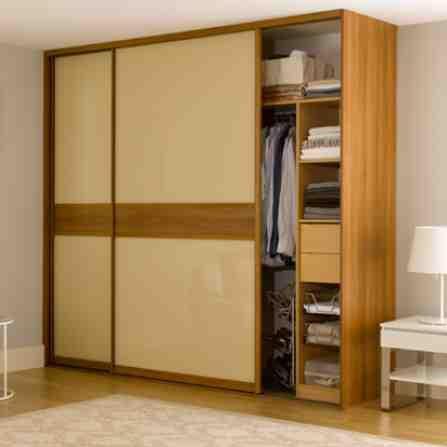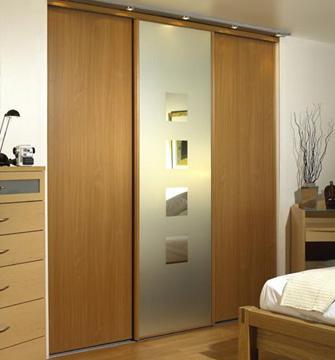The first image is the image on the left, the second image is the image on the right. Assess this claim about the two images: "An image shows a wardrobe with pale beige panels and the sliding door partly open.". Correct or not? Answer yes or no. Yes. The first image is the image on the left, the second image is the image on the right. Analyze the images presented: Is the assertion "There are clothes visible in one of the closets." valid? Answer yes or no. Yes. 